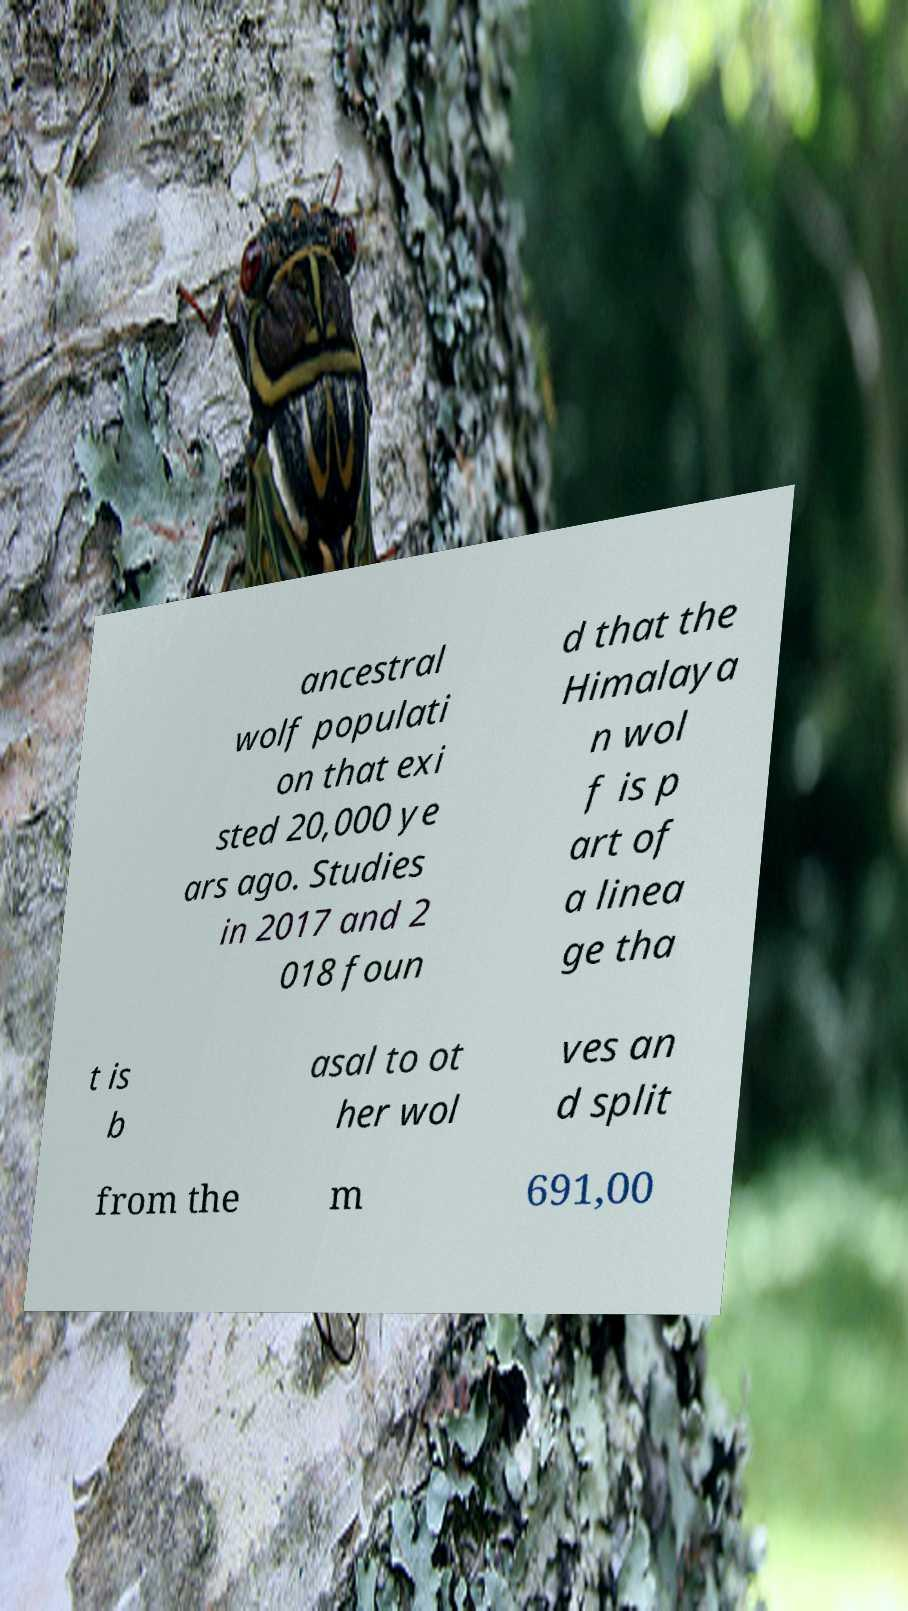For documentation purposes, I need the text within this image transcribed. Could you provide that? ancestral wolf populati on that exi sted 20,000 ye ars ago. Studies in 2017 and 2 018 foun d that the Himalaya n wol f is p art of a linea ge tha t is b asal to ot her wol ves an d split from the m 691,00 